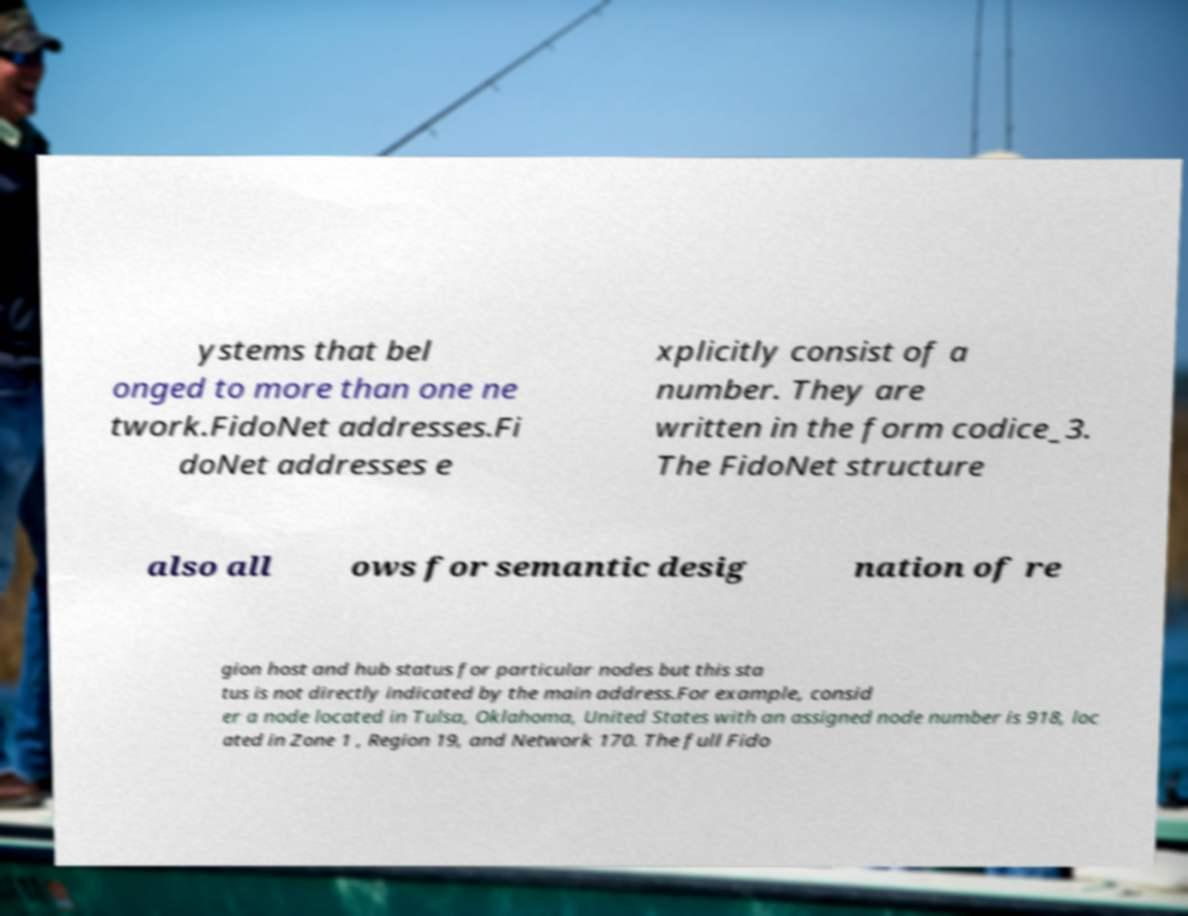I need the written content from this picture converted into text. Can you do that? ystems that bel onged to more than one ne twork.FidoNet addresses.Fi doNet addresses e xplicitly consist of a number. They are written in the form codice_3. The FidoNet structure also all ows for semantic desig nation of re gion host and hub status for particular nodes but this sta tus is not directly indicated by the main address.For example, consid er a node located in Tulsa, Oklahoma, United States with an assigned node number is 918, loc ated in Zone 1 , Region 19, and Network 170. The full Fido 